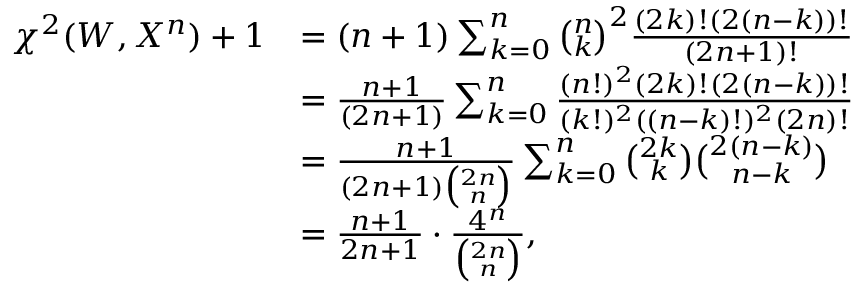Convert formula to latex. <formula><loc_0><loc_0><loc_500><loc_500>\begin{array} { r l } { \chi ^ { 2 } ( W , X ^ { n } ) + 1 } & { = ( n + 1 ) \sum _ { k = 0 } ^ { n } \binom { n } { k } ^ { 2 } \frac { ( 2 k ) ! ( 2 ( n - k ) ) ! } { ( 2 n + 1 ) ! } } \\ & { = \frac { n + 1 } { ( 2 n + 1 ) } \sum _ { k = 0 } ^ { n } \frac { ( n ! ) ^ { 2 } ( 2 k ) ! ( 2 ( n - k ) ) ! } { ( k ! ) ^ { 2 } ( ( n - k ) ! ) ^ { 2 } ( 2 n ) ! } } \\ & { = \frac { n + 1 } { ( 2 n + 1 ) \binom { 2 n } { n } } \sum _ { k = 0 } ^ { n } \binom { 2 k } { k } \binom { 2 ( n - k ) } { n - k } } \\ & { = \frac { n + 1 } { 2 n + 1 } \cdot \frac { 4 ^ { n } } { \binom { 2 n } { n } } , } \end{array}</formula> 